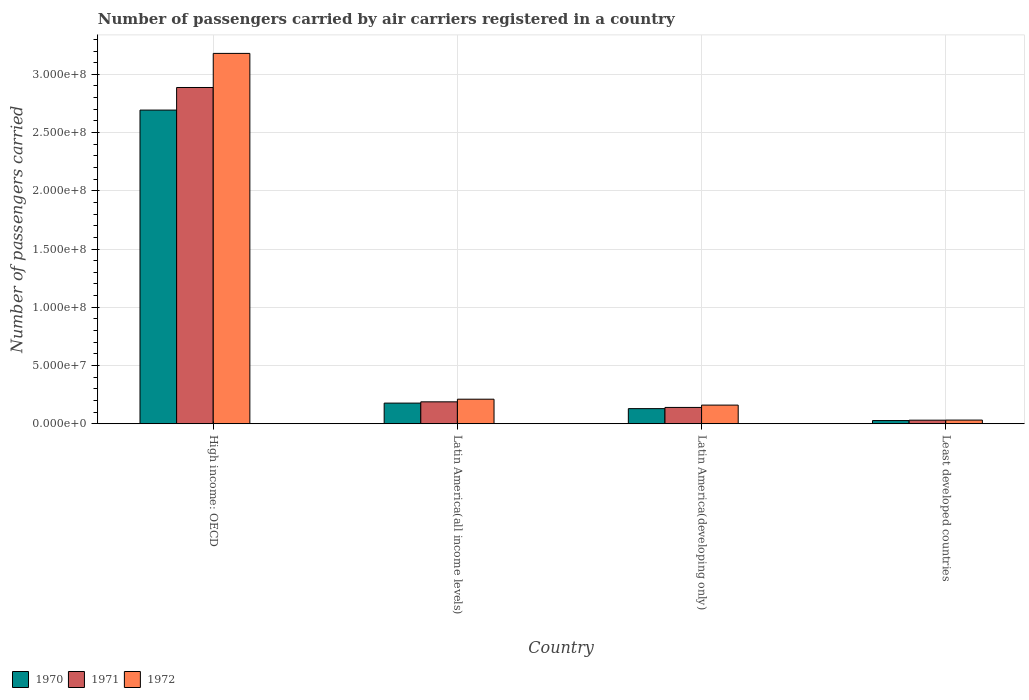How many different coloured bars are there?
Your answer should be very brief. 3. How many bars are there on the 2nd tick from the left?
Your answer should be compact. 3. How many bars are there on the 3rd tick from the right?
Provide a succinct answer. 3. What is the label of the 3rd group of bars from the left?
Provide a short and direct response. Latin America(developing only). In how many cases, is the number of bars for a given country not equal to the number of legend labels?
Your response must be concise. 0. What is the number of passengers carried by air carriers in 1971 in Latin America(all income levels)?
Your response must be concise. 1.88e+07. Across all countries, what is the maximum number of passengers carried by air carriers in 1971?
Your response must be concise. 2.89e+08. Across all countries, what is the minimum number of passengers carried by air carriers in 1971?
Provide a succinct answer. 3.05e+06. In which country was the number of passengers carried by air carriers in 1972 maximum?
Offer a terse response. High income: OECD. In which country was the number of passengers carried by air carriers in 1972 minimum?
Ensure brevity in your answer.  Least developed countries. What is the total number of passengers carried by air carriers in 1970 in the graph?
Keep it short and to the point. 3.03e+08. What is the difference between the number of passengers carried by air carriers in 1972 in Latin America(all income levels) and that in Latin America(developing only)?
Your response must be concise. 5.08e+06. What is the difference between the number of passengers carried by air carriers in 1970 in High income: OECD and the number of passengers carried by air carriers in 1971 in Latin America(all income levels)?
Your response must be concise. 2.51e+08. What is the average number of passengers carried by air carriers in 1972 per country?
Ensure brevity in your answer.  8.96e+07. What is the difference between the number of passengers carried by air carriers of/in 1970 and number of passengers carried by air carriers of/in 1971 in Least developed countries?
Offer a terse response. -3.23e+05. In how many countries, is the number of passengers carried by air carriers in 1971 greater than 50000000?
Your answer should be very brief. 1. What is the ratio of the number of passengers carried by air carriers in 1972 in Latin America(developing only) to that in Least developed countries?
Provide a succinct answer. 5.1. Is the difference between the number of passengers carried by air carriers in 1970 in High income: OECD and Least developed countries greater than the difference between the number of passengers carried by air carriers in 1971 in High income: OECD and Least developed countries?
Offer a terse response. No. What is the difference between the highest and the second highest number of passengers carried by air carriers in 1970?
Offer a terse response. -4.74e+06. What is the difference between the highest and the lowest number of passengers carried by air carriers in 1972?
Make the answer very short. 3.15e+08. In how many countries, is the number of passengers carried by air carriers in 1971 greater than the average number of passengers carried by air carriers in 1971 taken over all countries?
Offer a terse response. 1. What does the 2nd bar from the left in Least developed countries represents?
Provide a short and direct response. 1971. What does the 2nd bar from the right in Latin America(all income levels) represents?
Offer a terse response. 1971. How many bars are there?
Provide a short and direct response. 12. How many countries are there in the graph?
Offer a very short reply. 4. Where does the legend appear in the graph?
Make the answer very short. Bottom left. How many legend labels are there?
Provide a succinct answer. 3. How are the legend labels stacked?
Provide a succinct answer. Horizontal. What is the title of the graph?
Provide a short and direct response. Number of passengers carried by air carriers registered in a country. Does "1960" appear as one of the legend labels in the graph?
Make the answer very short. No. What is the label or title of the X-axis?
Offer a very short reply. Country. What is the label or title of the Y-axis?
Ensure brevity in your answer.  Number of passengers carried. What is the Number of passengers carried of 1970 in High income: OECD?
Offer a terse response. 2.69e+08. What is the Number of passengers carried of 1971 in High income: OECD?
Give a very brief answer. 2.89e+08. What is the Number of passengers carried of 1972 in High income: OECD?
Keep it short and to the point. 3.18e+08. What is the Number of passengers carried in 1970 in Latin America(all income levels)?
Offer a very short reply. 1.77e+07. What is the Number of passengers carried in 1971 in Latin America(all income levels)?
Offer a very short reply. 1.88e+07. What is the Number of passengers carried of 1972 in Latin America(all income levels)?
Give a very brief answer. 2.11e+07. What is the Number of passengers carried in 1970 in Latin America(developing only)?
Give a very brief answer. 1.30e+07. What is the Number of passengers carried of 1971 in Latin America(developing only)?
Give a very brief answer. 1.40e+07. What is the Number of passengers carried of 1972 in Latin America(developing only)?
Ensure brevity in your answer.  1.60e+07. What is the Number of passengers carried of 1970 in Least developed countries?
Provide a succinct answer. 2.73e+06. What is the Number of passengers carried of 1971 in Least developed countries?
Your answer should be compact. 3.05e+06. What is the Number of passengers carried in 1972 in Least developed countries?
Your answer should be compact. 3.14e+06. Across all countries, what is the maximum Number of passengers carried of 1970?
Your response must be concise. 2.69e+08. Across all countries, what is the maximum Number of passengers carried in 1971?
Give a very brief answer. 2.89e+08. Across all countries, what is the maximum Number of passengers carried in 1972?
Keep it short and to the point. 3.18e+08. Across all countries, what is the minimum Number of passengers carried in 1970?
Ensure brevity in your answer.  2.73e+06. Across all countries, what is the minimum Number of passengers carried of 1971?
Offer a very short reply. 3.05e+06. Across all countries, what is the minimum Number of passengers carried of 1972?
Provide a short and direct response. 3.14e+06. What is the total Number of passengers carried of 1970 in the graph?
Your answer should be very brief. 3.03e+08. What is the total Number of passengers carried of 1971 in the graph?
Make the answer very short. 3.25e+08. What is the total Number of passengers carried of 1972 in the graph?
Your answer should be very brief. 3.58e+08. What is the difference between the Number of passengers carried of 1970 in High income: OECD and that in Latin America(all income levels)?
Offer a terse response. 2.52e+08. What is the difference between the Number of passengers carried of 1971 in High income: OECD and that in Latin America(all income levels)?
Ensure brevity in your answer.  2.70e+08. What is the difference between the Number of passengers carried of 1972 in High income: OECD and that in Latin America(all income levels)?
Ensure brevity in your answer.  2.97e+08. What is the difference between the Number of passengers carried in 1970 in High income: OECD and that in Latin America(developing only)?
Provide a succinct answer. 2.56e+08. What is the difference between the Number of passengers carried in 1971 in High income: OECD and that in Latin America(developing only)?
Offer a very short reply. 2.75e+08. What is the difference between the Number of passengers carried of 1972 in High income: OECD and that in Latin America(developing only)?
Your answer should be very brief. 3.02e+08. What is the difference between the Number of passengers carried in 1970 in High income: OECD and that in Least developed countries?
Provide a succinct answer. 2.67e+08. What is the difference between the Number of passengers carried in 1971 in High income: OECD and that in Least developed countries?
Ensure brevity in your answer.  2.86e+08. What is the difference between the Number of passengers carried of 1972 in High income: OECD and that in Least developed countries?
Ensure brevity in your answer.  3.15e+08. What is the difference between the Number of passengers carried of 1970 in Latin America(all income levels) and that in Latin America(developing only)?
Offer a very short reply. 4.74e+06. What is the difference between the Number of passengers carried of 1971 in Latin America(all income levels) and that in Latin America(developing only)?
Provide a short and direct response. 4.81e+06. What is the difference between the Number of passengers carried in 1972 in Latin America(all income levels) and that in Latin America(developing only)?
Your answer should be very brief. 5.08e+06. What is the difference between the Number of passengers carried of 1970 in Latin America(all income levels) and that in Least developed countries?
Offer a very short reply. 1.50e+07. What is the difference between the Number of passengers carried of 1971 in Latin America(all income levels) and that in Least developed countries?
Give a very brief answer. 1.58e+07. What is the difference between the Number of passengers carried of 1972 in Latin America(all income levels) and that in Least developed countries?
Your answer should be very brief. 1.79e+07. What is the difference between the Number of passengers carried of 1970 in Latin America(developing only) and that in Least developed countries?
Provide a succinct answer. 1.02e+07. What is the difference between the Number of passengers carried in 1971 in Latin America(developing only) and that in Least developed countries?
Offer a very short reply. 1.09e+07. What is the difference between the Number of passengers carried of 1972 in Latin America(developing only) and that in Least developed countries?
Your answer should be compact. 1.29e+07. What is the difference between the Number of passengers carried of 1970 in High income: OECD and the Number of passengers carried of 1971 in Latin America(all income levels)?
Ensure brevity in your answer.  2.51e+08. What is the difference between the Number of passengers carried in 1970 in High income: OECD and the Number of passengers carried in 1972 in Latin America(all income levels)?
Provide a short and direct response. 2.48e+08. What is the difference between the Number of passengers carried of 1971 in High income: OECD and the Number of passengers carried of 1972 in Latin America(all income levels)?
Make the answer very short. 2.68e+08. What is the difference between the Number of passengers carried in 1970 in High income: OECD and the Number of passengers carried in 1971 in Latin America(developing only)?
Your answer should be compact. 2.55e+08. What is the difference between the Number of passengers carried of 1970 in High income: OECD and the Number of passengers carried of 1972 in Latin America(developing only)?
Provide a succinct answer. 2.53e+08. What is the difference between the Number of passengers carried of 1971 in High income: OECD and the Number of passengers carried of 1972 in Latin America(developing only)?
Offer a very short reply. 2.73e+08. What is the difference between the Number of passengers carried of 1970 in High income: OECD and the Number of passengers carried of 1971 in Least developed countries?
Keep it short and to the point. 2.66e+08. What is the difference between the Number of passengers carried of 1970 in High income: OECD and the Number of passengers carried of 1972 in Least developed countries?
Your answer should be very brief. 2.66e+08. What is the difference between the Number of passengers carried in 1971 in High income: OECD and the Number of passengers carried in 1972 in Least developed countries?
Your answer should be compact. 2.86e+08. What is the difference between the Number of passengers carried of 1970 in Latin America(all income levels) and the Number of passengers carried of 1971 in Latin America(developing only)?
Provide a short and direct response. 3.71e+06. What is the difference between the Number of passengers carried in 1970 in Latin America(all income levels) and the Number of passengers carried in 1972 in Latin America(developing only)?
Ensure brevity in your answer.  1.71e+06. What is the difference between the Number of passengers carried in 1971 in Latin America(all income levels) and the Number of passengers carried in 1972 in Latin America(developing only)?
Provide a succinct answer. 2.81e+06. What is the difference between the Number of passengers carried of 1970 in Latin America(all income levels) and the Number of passengers carried of 1971 in Least developed countries?
Your response must be concise. 1.47e+07. What is the difference between the Number of passengers carried of 1970 in Latin America(all income levels) and the Number of passengers carried of 1972 in Least developed countries?
Your answer should be compact. 1.46e+07. What is the difference between the Number of passengers carried in 1971 in Latin America(all income levels) and the Number of passengers carried in 1972 in Least developed countries?
Give a very brief answer. 1.57e+07. What is the difference between the Number of passengers carried of 1970 in Latin America(developing only) and the Number of passengers carried of 1971 in Least developed countries?
Give a very brief answer. 9.92e+06. What is the difference between the Number of passengers carried of 1970 in Latin America(developing only) and the Number of passengers carried of 1972 in Least developed countries?
Your answer should be compact. 9.84e+06. What is the difference between the Number of passengers carried of 1971 in Latin America(developing only) and the Number of passengers carried of 1972 in Least developed countries?
Your answer should be compact. 1.09e+07. What is the average Number of passengers carried of 1970 per country?
Provide a short and direct response. 7.57e+07. What is the average Number of passengers carried of 1971 per country?
Your response must be concise. 8.11e+07. What is the average Number of passengers carried of 1972 per country?
Make the answer very short. 8.96e+07. What is the difference between the Number of passengers carried of 1970 and Number of passengers carried of 1971 in High income: OECD?
Your answer should be very brief. -1.94e+07. What is the difference between the Number of passengers carried of 1970 and Number of passengers carried of 1972 in High income: OECD?
Make the answer very short. -4.87e+07. What is the difference between the Number of passengers carried of 1971 and Number of passengers carried of 1972 in High income: OECD?
Keep it short and to the point. -2.93e+07. What is the difference between the Number of passengers carried of 1970 and Number of passengers carried of 1971 in Latin America(all income levels)?
Make the answer very short. -1.09e+06. What is the difference between the Number of passengers carried in 1970 and Number of passengers carried in 1972 in Latin America(all income levels)?
Ensure brevity in your answer.  -3.36e+06. What is the difference between the Number of passengers carried of 1971 and Number of passengers carried of 1972 in Latin America(all income levels)?
Ensure brevity in your answer.  -2.27e+06. What is the difference between the Number of passengers carried of 1970 and Number of passengers carried of 1971 in Latin America(developing only)?
Provide a short and direct response. -1.03e+06. What is the difference between the Number of passengers carried in 1970 and Number of passengers carried in 1972 in Latin America(developing only)?
Offer a very short reply. -3.03e+06. What is the difference between the Number of passengers carried of 1971 and Number of passengers carried of 1972 in Latin America(developing only)?
Offer a terse response. -2.00e+06. What is the difference between the Number of passengers carried in 1970 and Number of passengers carried in 1971 in Least developed countries?
Your answer should be very brief. -3.23e+05. What is the difference between the Number of passengers carried of 1970 and Number of passengers carried of 1972 in Least developed countries?
Give a very brief answer. -4.07e+05. What is the difference between the Number of passengers carried of 1971 and Number of passengers carried of 1972 in Least developed countries?
Provide a succinct answer. -8.41e+04. What is the ratio of the Number of passengers carried of 1970 in High income: OECD to that in Latin America(all income levels)?
Offer a very short reply. 15.2. What is the ratio of the Number of passengers carried of 1971 in High income: OECD to that in Latin America(all income levels)?
Your response must be concise. 15.35. What is the ratio of the Number of passengers carried of 1972 in High income: OECD to that in Latin America(all income levels)?
Your answer should be very brief. 15.09. What is the ratio of the Number of passengers carried of 1970 in High income: OECD to that in Latin America(developing only)?
Offer a very short reply. 20.75. What is the ratio of the Number of passengers carried of 1971 in High income: OECD to that in Latin America(developing only)?
Offer a very short reply. 20.62. What is the ratio of the Number of passengers carried in 1972 in High income: OECD to that in Latin America(developing only)?
Make the answer very short. 19.87. What is the ratio of the Number of passengers carried in 1970 in High income: OECD to that in Least developed countries?
Offer a very short reply. 98.62. What is the ratio of the Number of passengers carried in 1971 in High income: OECD to that in Least developed countries?
Make the answer very short. 94.54. What is the ratio of the Number of passengers carried in 1972 in High income: OECD to that in Least developed countries?
Your response must be concise. 101.33. What is the ratio of the Number of passengers carried in 1970 in Latin America(all income levels) to that in Latin America(developing only)?
Your answer should be very brief. 1.37. What is the ratio of the Number of passengers carried in 1971 in Latin America(all income levels) to that in Latin America(developing only)?
Ensure brevity in your answer.  1.34. What is the ratio of the Number of passengers carried in 1972 in Latin America(all income levels) to that in Latin America(developing only)?
Your response must be concise. 1.32. What is the ratio of the Number of passengers carried in 1970 in Latin America(all income levels) to that in Least developed countries?
Ensure brevity in your answer.  6.49. What is the ratio of the Number of passengers carried in 1971 in Latin America(all income levels) to that in Least developed countries?
Keep it short and to the point. 6.16. What is the ratio of the Number of passengers carried in 1972 in Latin America(all income levels) to that in Least developed countries?
Provide a short and direct response. 6.72. What is the ratio of the Number of passengers carried in 1970 in Latin America(developing only) to that in Least developed countries?
Give a very brief answer. 4.75. What is the ratio of the Number of passengers carried of 1971 in Latin America(developing only) to that in Least developed countries?
Provide a short and direct response. 4.59. What is the ratio of the Number of passengers carried in 1972 in Latin America(developing only) to that in Least developed countries?
Keep it short and to the point. 5.1. What is the difference between the highest and the second highest Number of passengers carried of 1970?
Make the answer very short. 2.52e+08. What is the difference between the highest and the second highest Number of passengers carried of 1971?
Your response must be concise. 2.70e+08. What is the difference between the highest and the second highest Number of passengers carried of 1972?
Offer a terse response. 2.97e+08. What is the difference between the highest and the lowest Number of passengers carried of 1970?
Offer a very short reply. 2.67e+08. What is the difference between the highest and the lowest Number of passengers carried in 1971?
Provide a succinct answer. 2.86e+08. What is the difference between the highest and the lowest Number of passengers carried of 1972?
Your answer should be compact. 3.15e+08. 